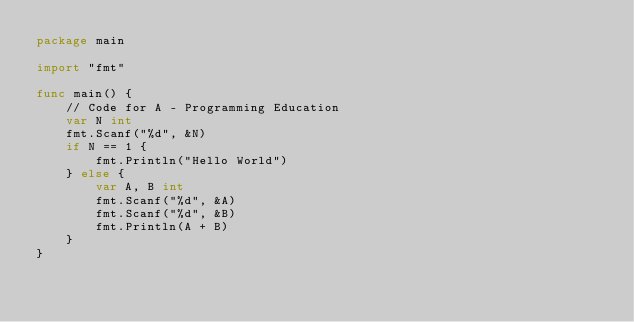<code> <loc_0><loc_0><loc_500><loc_500><_Go_>package main

import "fmt"

func main() {
	// Code for A - Programming Education
	var N int
	fmt.Scanf("%d", &N)
	if N == 1 {
		fmt.Println("Hello World")
	} else {
		var A, B int
		fmt.Scanf("%d", &A)
		fmt.Scanf("%d", &B)
		fmt.Println(A + B)
	}
}
</code> 